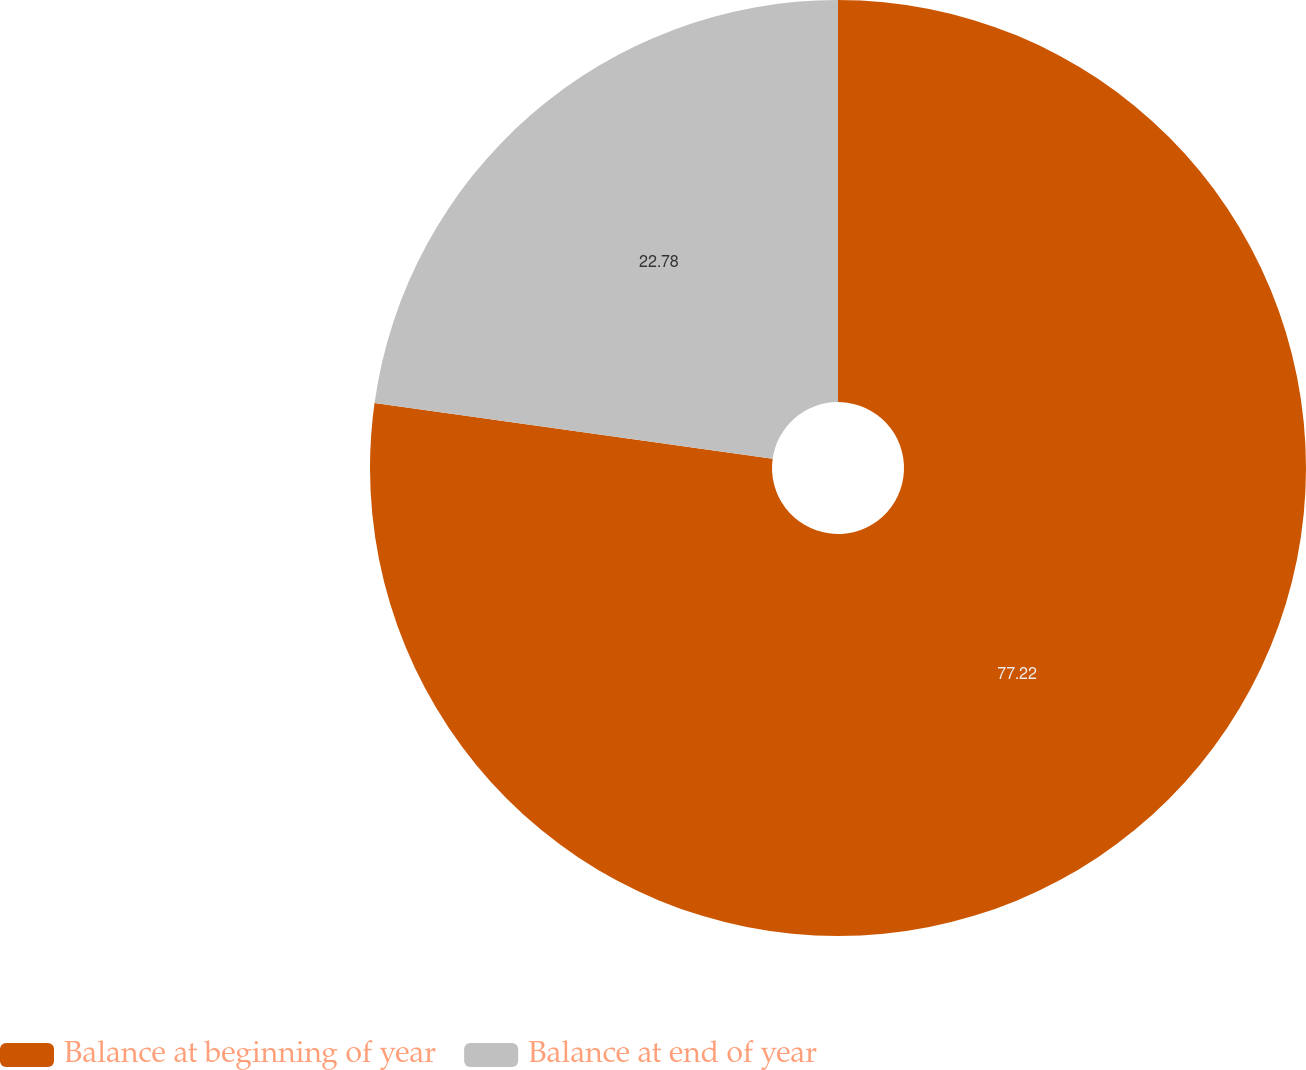Convert chart to OTSL. <chart><loc_0><loc_0><loc_500><loc_500><pie_chart><fcel>Balance at beginning of year<fcel>Balance at end of year<nl><fcel>77.22%<fcel>22.78%<nl></chart> 